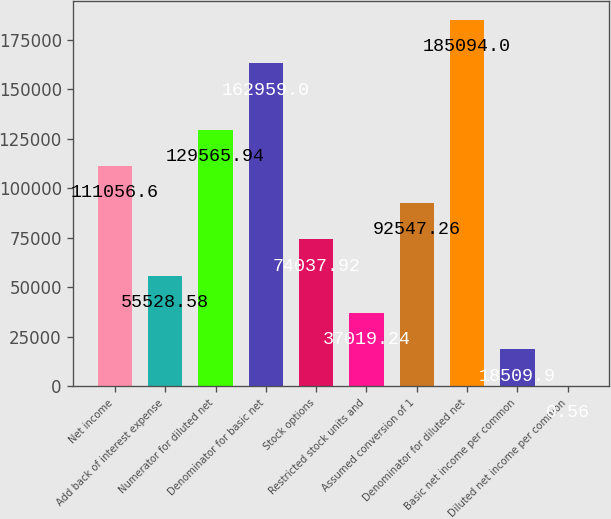<chart> <loc_0><loc_0><loc_500><loc_500><bar_chart><fcel>Net income<fcel>Add back of interest expense<fcel>Numerator for diluted net<fcel>Denominator for basic net<fcel>Stock options<fcel>Restricted stock units and<fcel>Assumed conversion of 1<fcel>Denominator for diluted net<fcel>Basic net income per common<fcel>Diluted net income per common<nl><fcel>111057<fcel>55528.6<fcel>129566<fcel>162959<fcel>74037.9<fcel>37019.2<fcel>92547.3<fcel>185094<fcel>18509.9<fcel>0.56<nl></chart> 